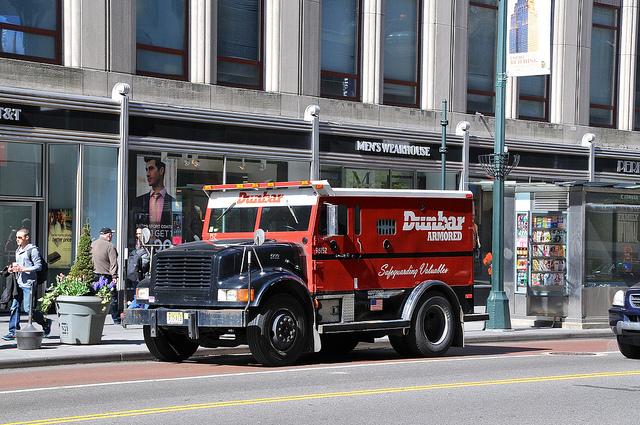Is there a parade?
Keep it brief. No. What kind of truck?
Answer briefly. Armored. What type of truck is pictured?
Short answer required. Armored. What kind of truck is this?
Give a very brief answer. Armored truck. What is this vehicle used for?
Answer briefly. Money. Are there any people in the truck?
Keep it brief. Yes. Is there any greenery in this picture?
Concise answer only. Yes. Why is the man holding a jacket?
Answer briefly. He is not cold. What is flying on a pole over the building?
Be succinct. Flag. Is there a ladder on the truck?
Write a very short answer. No. What is the function of the truck pictured here?
Be succinct. Armored. 